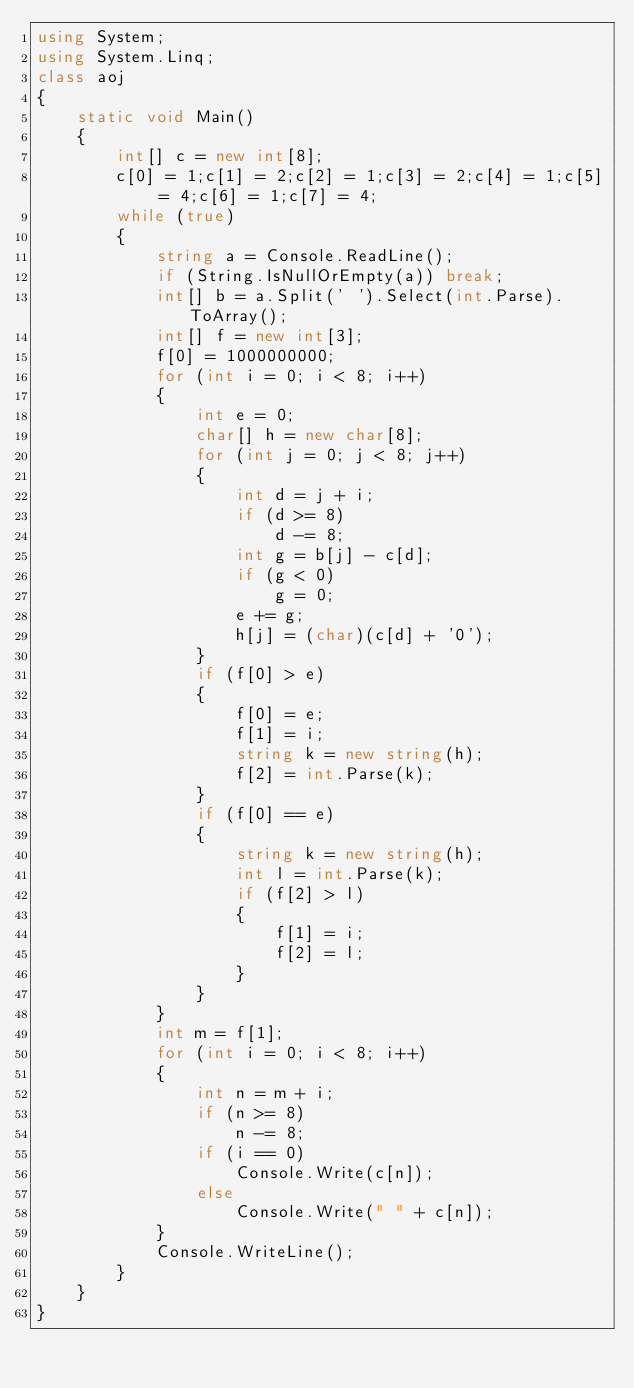<code> <loc_0><loc_0><loc_500><loc_500><_C#_>using System;
using System.Linq;
class aoj
{
    static void Main()
    {
        int[] c = new int[8];
        c[0] = 1;c[1] = 2;c[2] = 1;c[3] = 2;c[4] = 1;c[5] = 4;c[6] = 1;c[7] = 4;
        while (true)
        {
            string a = Console.ReadLine();
            if (String.IsNullOrEmpty(a)) break;
            int[] b = a.Split(' ').Select(int.Parse).ToArray();
            int[] f = new int[3];
            f[0] = 1000000000;
            for (int i = 0; i < 8; i++)
            {
                int e = 0;
                char[] h = new char[8];
                for (int j = 0; j < 8; j++)
                {
                    int d = j + i;
                    if (d >= 8)
                        d -= 8;
                    int g = b[j] - c[d];
                    if (g < 0)
                        g = 0;
                    e += g;
                    h[j] = (char)(c[d] + '0');
                }
                if (f[0] > e)
                {
                    f[0] = e;
                    f[1] = i;
                    string k = new string(h);
                    f[2] = int.Parse(k);
                }
                if (f[0] == e)
                {
                    string k = new string(h);
                    int l = int.Parse(k);
                    if (f[2] > l)
                    {
                        f[1] = i;
                        f[2] = l;
                    }
                }
            }
            int m = f[1];
            for (int i = 0; i < 8; i++)
            {
                int n = m + i;
                if (n >= 8)
                    n -= 8;
                if (i == 0)
                    Console.Write(c[n]);
                else
                    Console.Write(" " + c[n]);
            }
            Console.WriteLine();
        }
    }
}</code> 